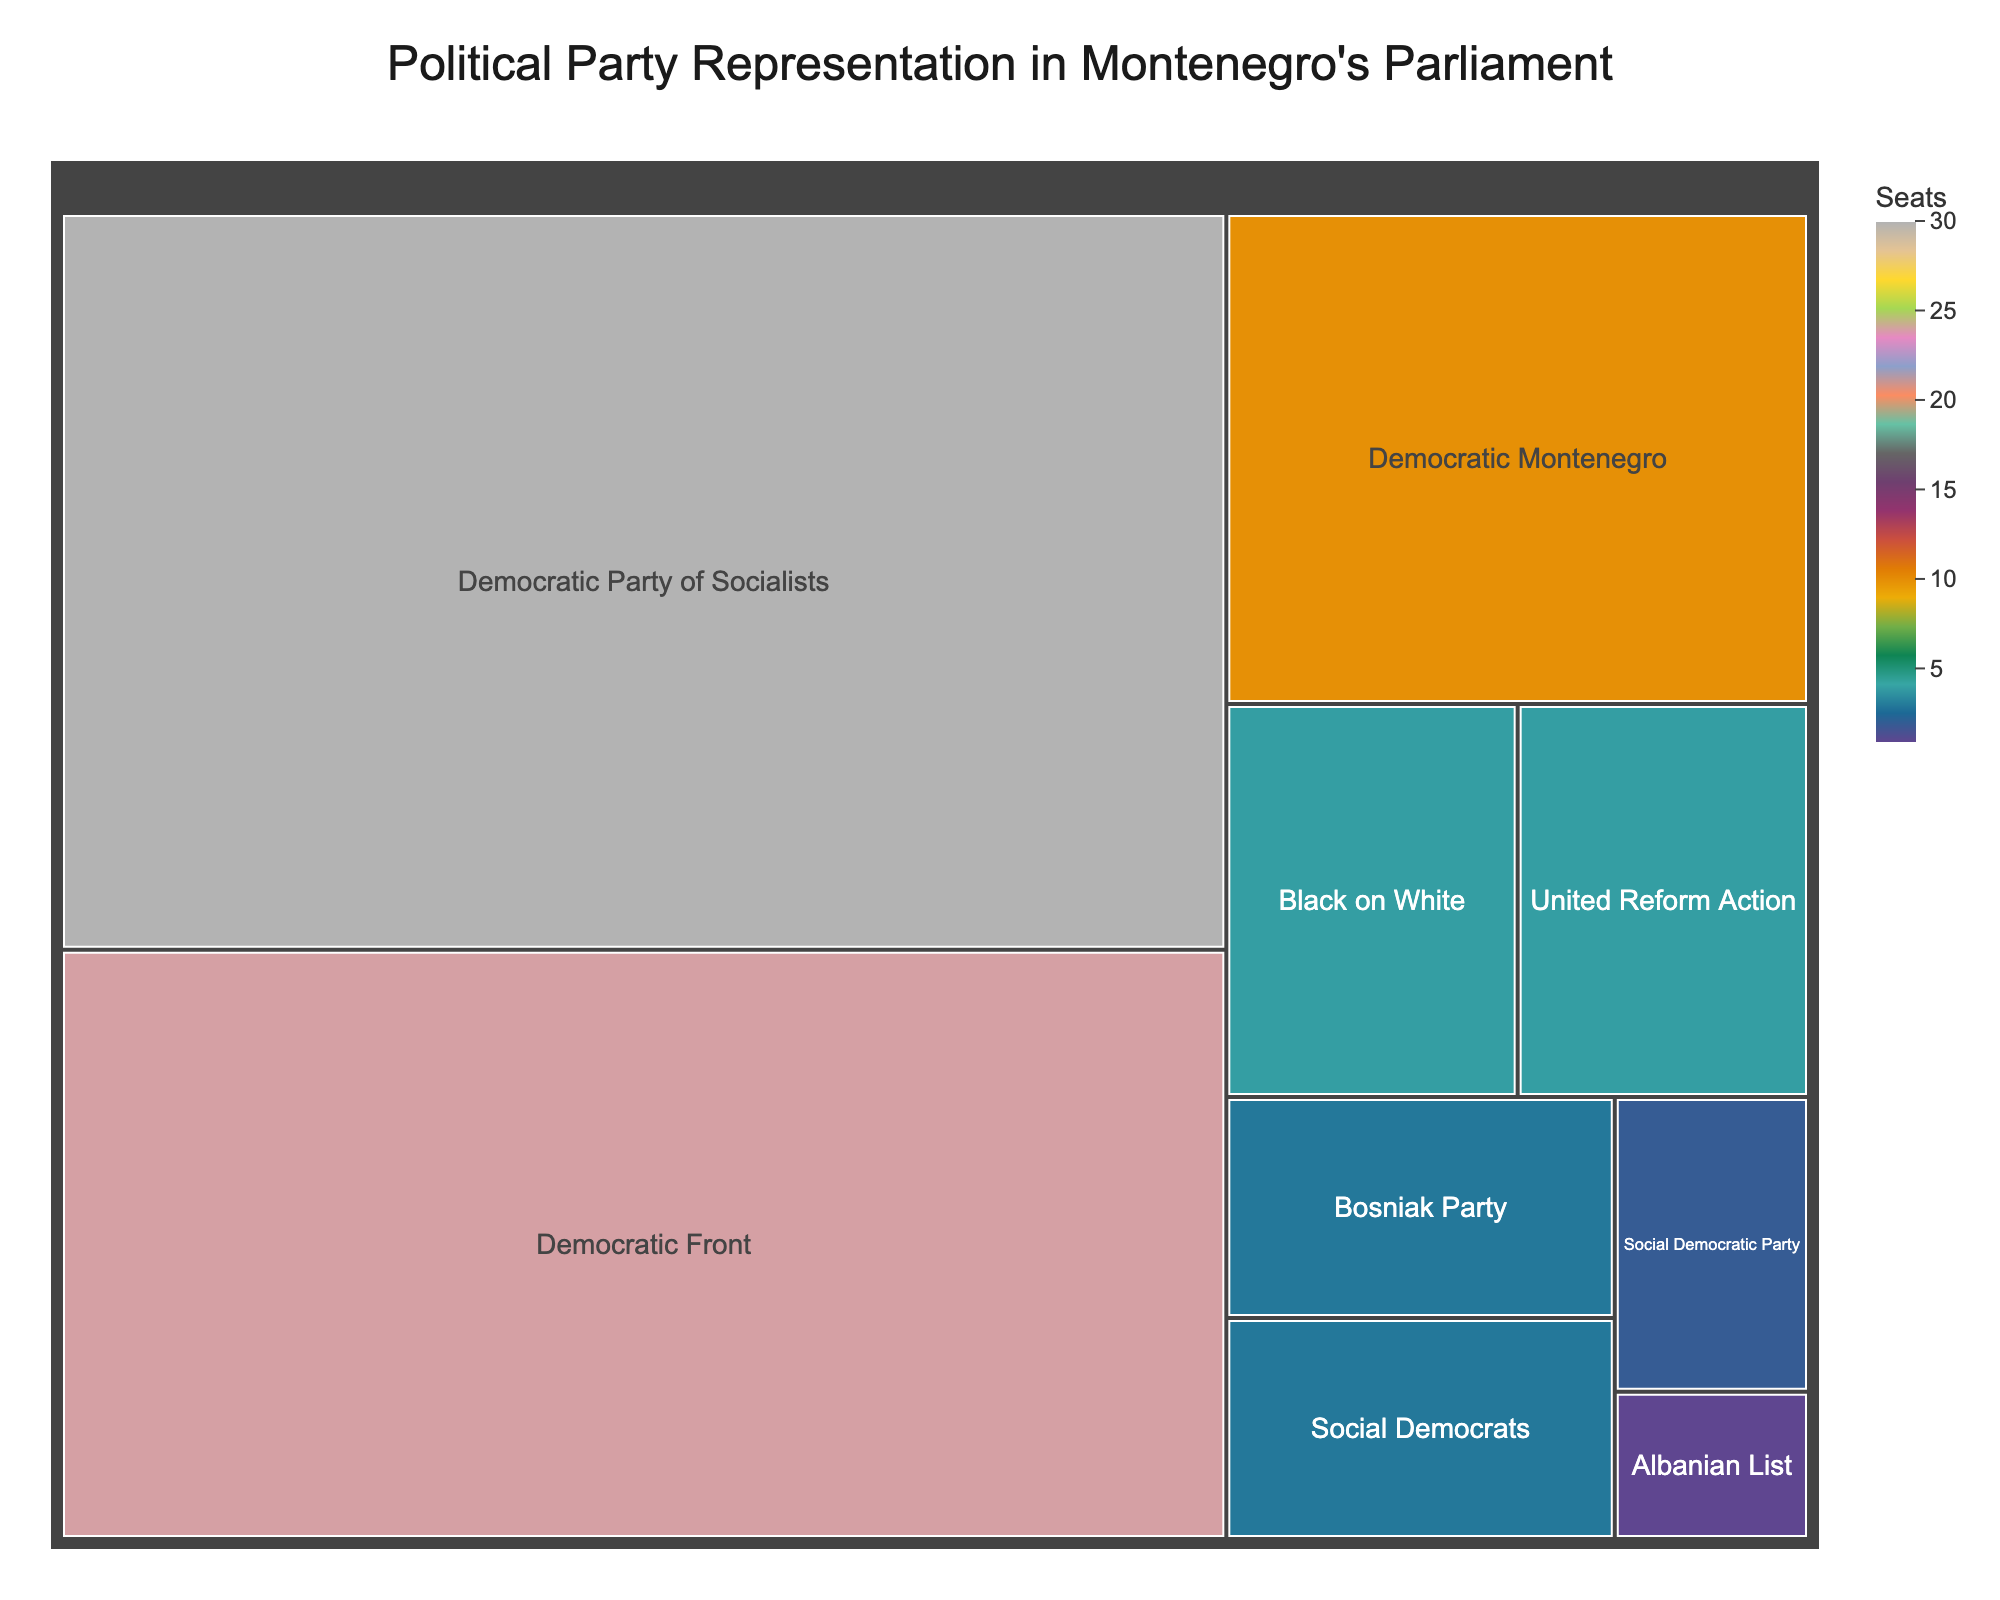How many seats does the Democratic Party of Socialists hold? Look for the Democratic Party of Socialists on the treemap and refer to the number of seats they hold.
Answer: 30 What is the smallest number of seats held by a party? Find the party with the smallest representation by counting the lowest number of seats.
Answer: 1 How many parties have exactly 3 seats? Check the number of parties listed with exactly 3 seats from the data provided in the treemap.
Answer: 2 Which party holds the second highest number of seats? Identify the party which has the second largest block in the treemap by the number of seats, after the Democratic Party of Socialists.
Answer: Democratic Front What is the total number of seats held by the parties with less than 5 seats each? Add up the seats of parties that have less than 5 seats: United Reform Action, Social Democrats, Bosniak Party, Social Democratic Party, Black on White, and Albanian List.
Answer: 17 How does the representation of the Democratic Montenegro compare with the United Reform Action? Compare the number of seats of Democratic Montenegro and United Reform Action by visually assessing their blocks.
Answer: Democratic Montenegro has 6 more seats than United Reform Action Is there a significant visual size difference between the block of the Democratic Front and the Democratic Montenegro? Observe the difference in size of the blocks representing the Democratic Front and Democratic Montenegro in the treemap.
Answer: Yes By how many seats does the Democratic Front outnumber the Democratic Montenegro? Subtract the number of seats of Democratic Montenegro from those of the Democratic Front.
Answer: 14 What can you infer about the color intensity in relation to the number of seats? Understand the color scheme in the treemap to determine if higher seat numbers correlate with a more intense color.
Answer: Higher seat numbers correlate with a more intense color Name a party that holds exactly 4 seats. Look for the parties with a block representing 4 seats in the treemap.
Answer: United Reform Action or Black on White 